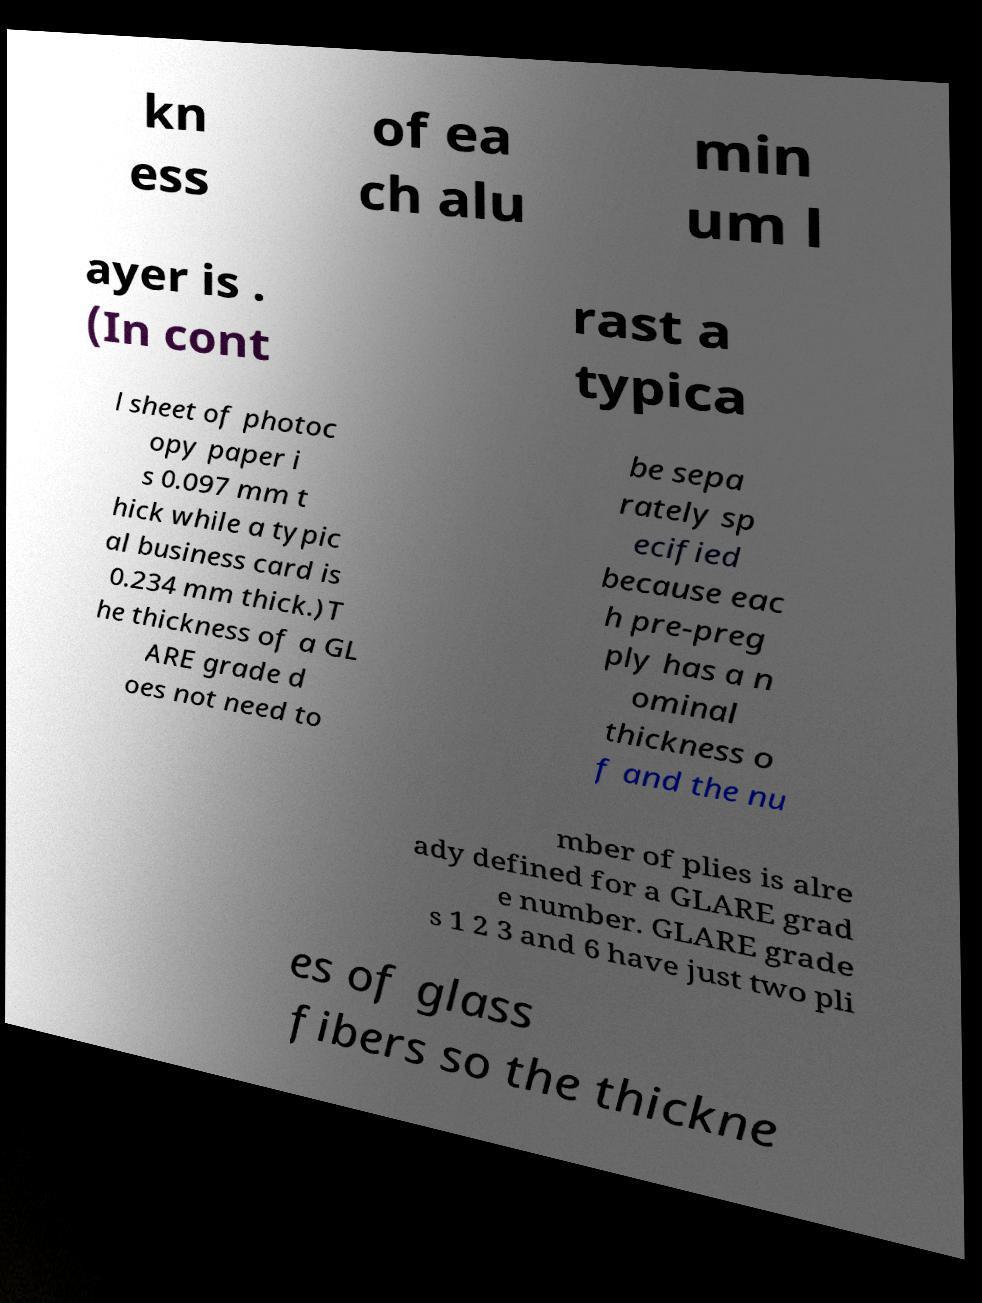Please read and relay the text visible in this image. What does it say? kn ess of ea ch alu min um l ayer is . (In cont rast a typica l sheet of photoc opy paper i s 0.097 mm t hick while a typic al business card is 0.234 mm thick.)T he thickness of a GL ARE grade d oes not need to be sepa rately sp ecified because eac h pre-preg ply has a n ominal thickness o f and the nu mber of plies is alre ady defined for a GLARE grad e number. GLARE grade s 1 2 3 and 6 have just two pli es of glass fibers so the thickne 